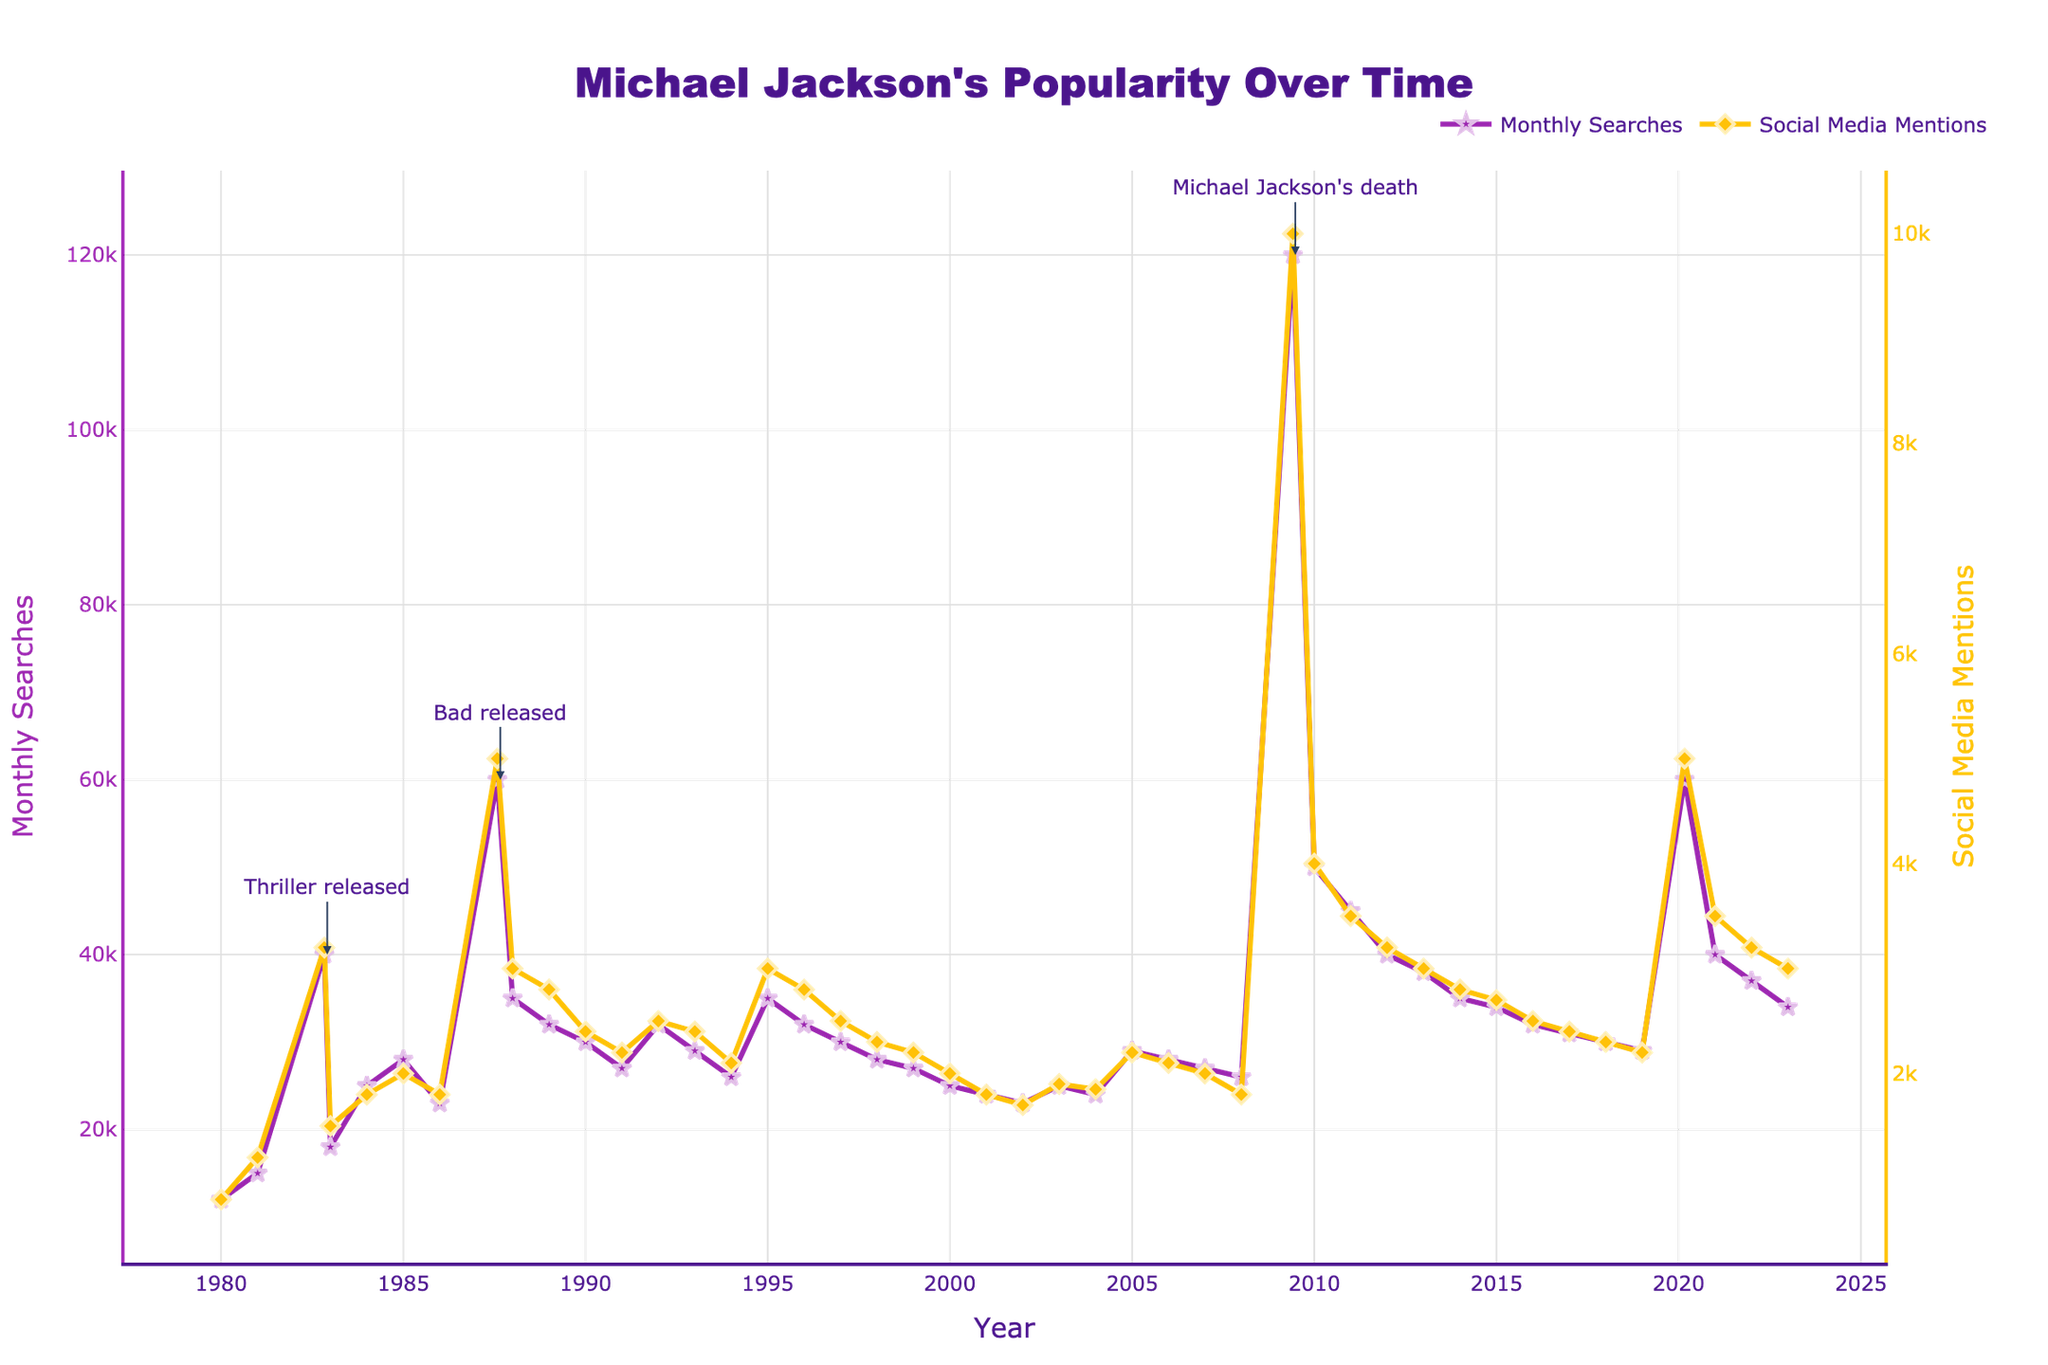What is the title of the figure? The title is displayed at the top center of the figure in large, bold font. It reads "Michael Jackson's Popularity Over Time".
Answer: Michael Jackson's Popularity Over Time How many annotations are on the plot? The figure contains annotated arrows pointing to significant events on the primary y-axis (Monthly Searches). Counting these arrows, there are three annotations.
Answer: 3 What significant event corresponds to the peak in monthly searches in 2009? By looking at the annotations around the peak in 2009, the arrow notes, "Michael Jackson's death".
Answer: Michael Jackson's death In what year was the "Thriller" album released according to the annotations? Referring to the annotations on the plot, the date specified for the "Thriller" release is November 1982.
Answer: 1982 How did Monthly Searches and Social Media Mentions compare in January 1995? Looking at the values on the left and right y-axes for January 1995, Monthly Searches were at 35,000 and Social Media Mentions were at 3,000.
Answer: Monthly Searches: 35,000, Social Media Mentions: 3,000 What was the overall trend in Monthly Searches from the 1980s through the early 2000s? Observing the plot, the Monthly Searches showed a general increase from the 1980s, peaking in the late 1980s, then a gradual decline which stabilized in the early 2000s.
Answer: Initially increasing, then declining and stabilizing During which month and year did Social Media Mentions first reach 5,000? Notice the Social Media Mentions trend and point out the first occurrence where 5,000 mentions were reached, which was in August 1987.
Answer: August 1987 Compare Monthly Searches' highest value to its lowest value. The highest value is 120,000 in June 2009, and the lowest is 12,000 in January 1980. Subtract the lowest from the highest: 120,000 - 12,000 = 108,000.
Answer: 108,000 How do Social Media Mentions in January 2023 compare to those in January 2021? Check the right y-axis for both dates. January 2023 had 3000 mentions while January 2021 had 3500 mentions; there is a decrease of 500.
Answer: Decreased by 500 Between the release of "Thriller" and "Bad", did Monthly Searches increase or decrease? Looking at the months just before November 1982 and August 1987, Monthly Searches increased from 40,000 to 60,000 during this period.
Answer: Increased 